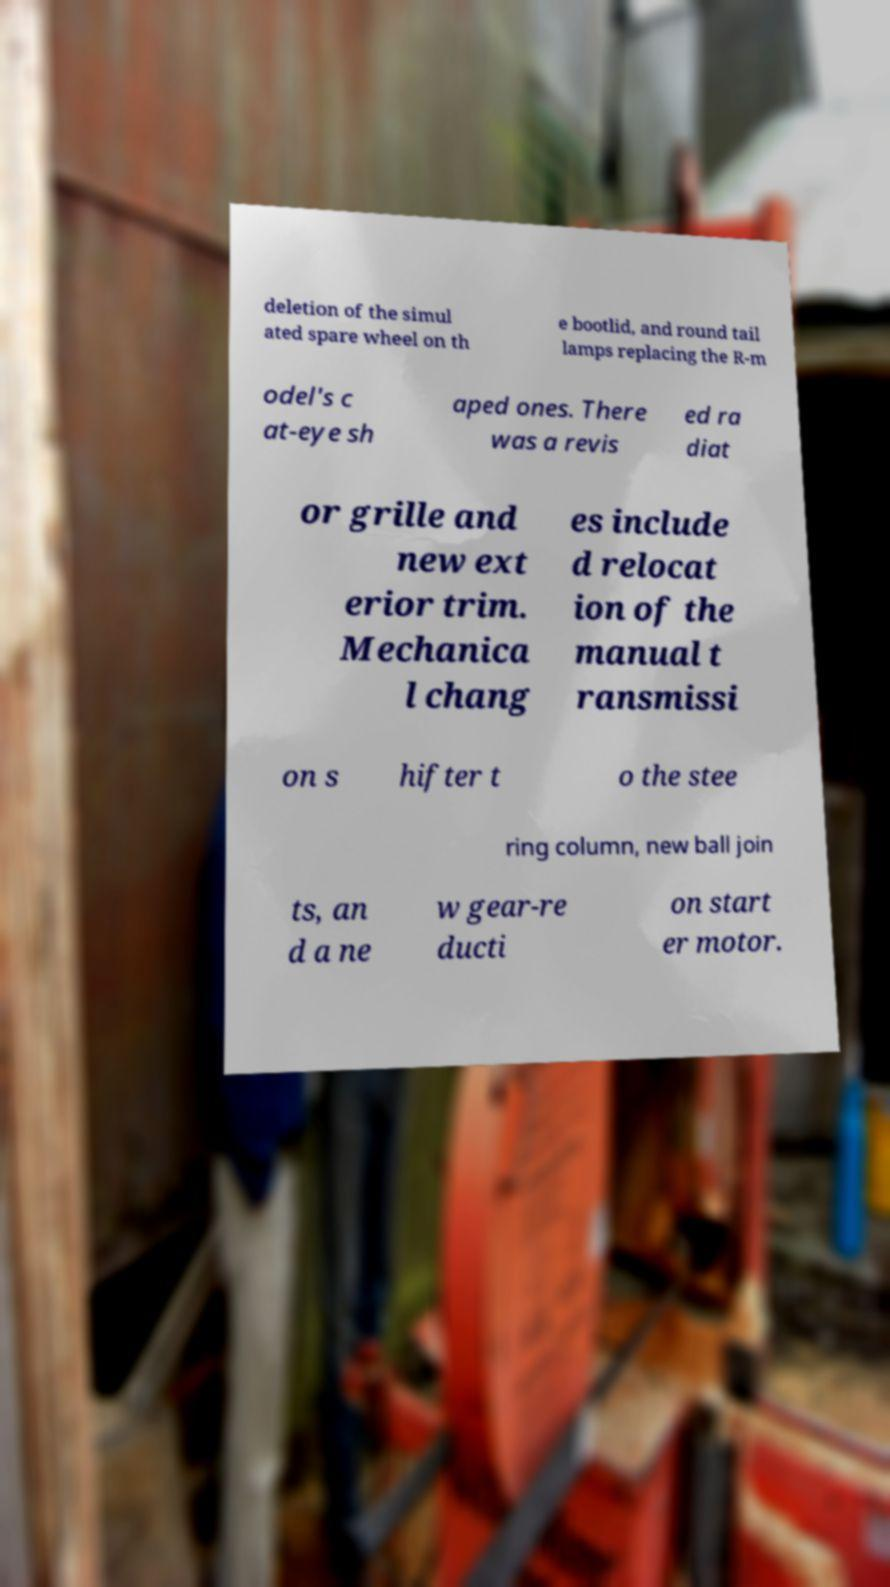Can you accurately transcribe the text from the provided image for me? deletion of the simul ated spare wheel on th e bootlid, and round tail lamps replacing the R-m odel's c at-eye sh aped ones. There was a revis ed ra diat or grille and new ext erior trim. Mechanica l chang es include d relocat ion of the manual t ransmissi on s hifter t o the stee ring column, new ball join ts, an d a ne w gear-re ducti on start er motor. 